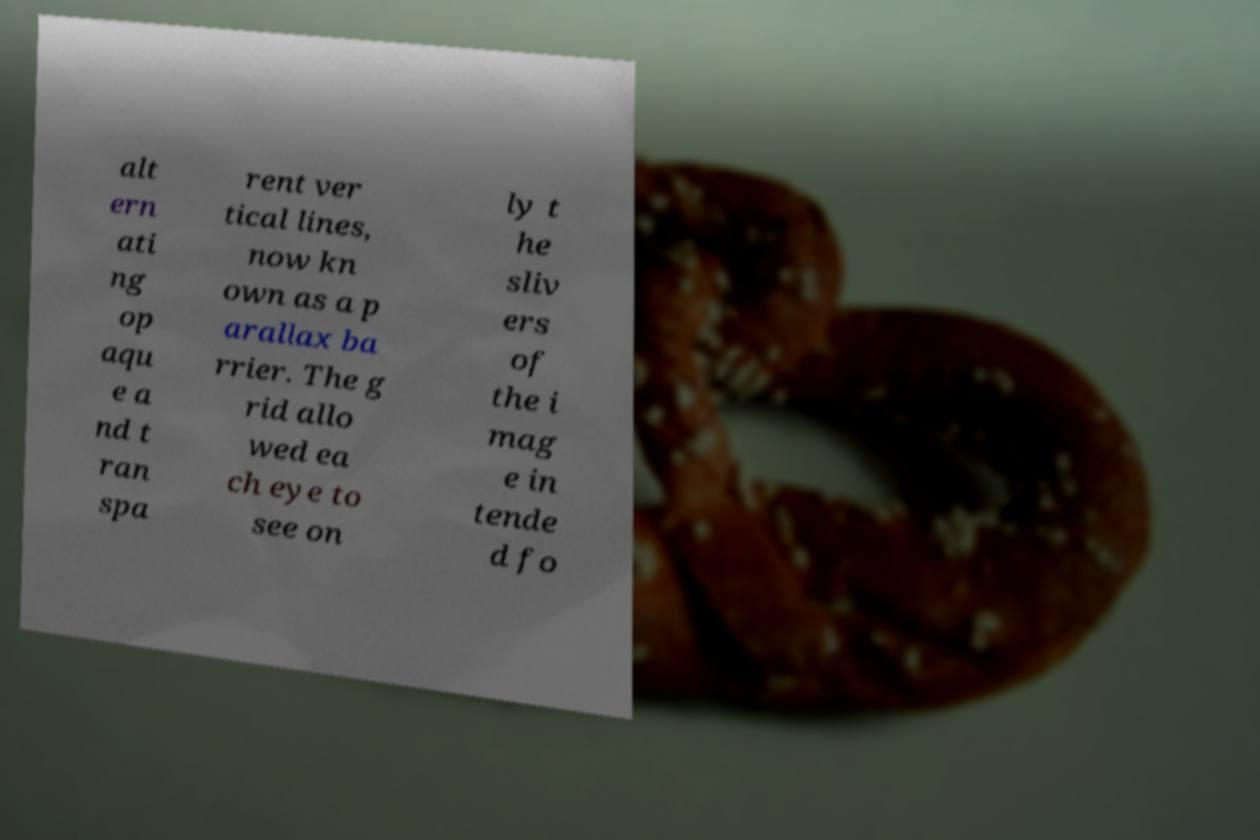What messages or text are displayed in this image? I need them in a readable, typed format. alt ern ati ng op aqu e a nd t ran spa rent ver tical lines, now kn own as a p arallax ba rrier. The g rid allo wed ea ch eye to see on ly t he sliv ers of the i mag e in tende d fo 